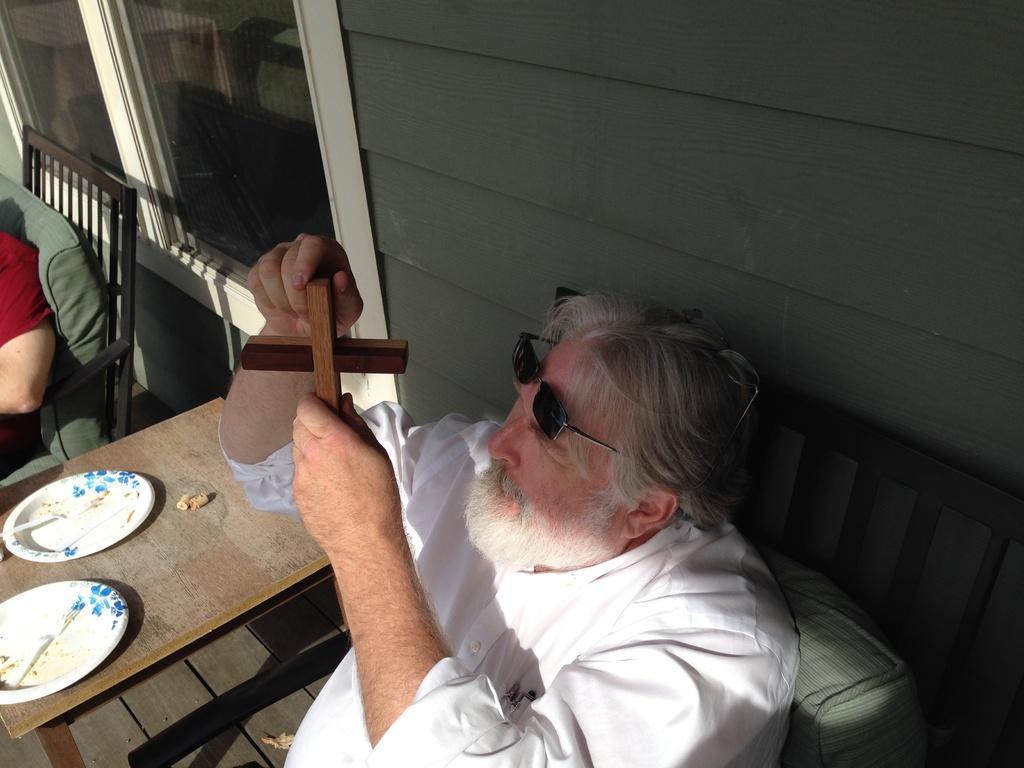How would you summarize this image in a sentence or two? In the picture a person is sitting on a chair with table in front of him on the table there are two plates he is catching a wooden pole near to the person there is a wall on the wall there is a window. 